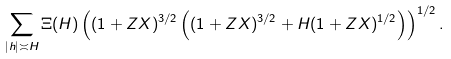<formula> <loc_0><loc_0><loc_500><loc_500>\sum _ { | h | \asymp H } \Xi ( H ) \left ( ( 1 + Z X ) ^ { 3 / 2 } \left ( ( 1 + Z X ) ^ { 3 / 2 } + H ( 1 + Z X ) ^ { 1 / 2 } \right ) \right ) ^ { 1 / 2 } .</formula> 